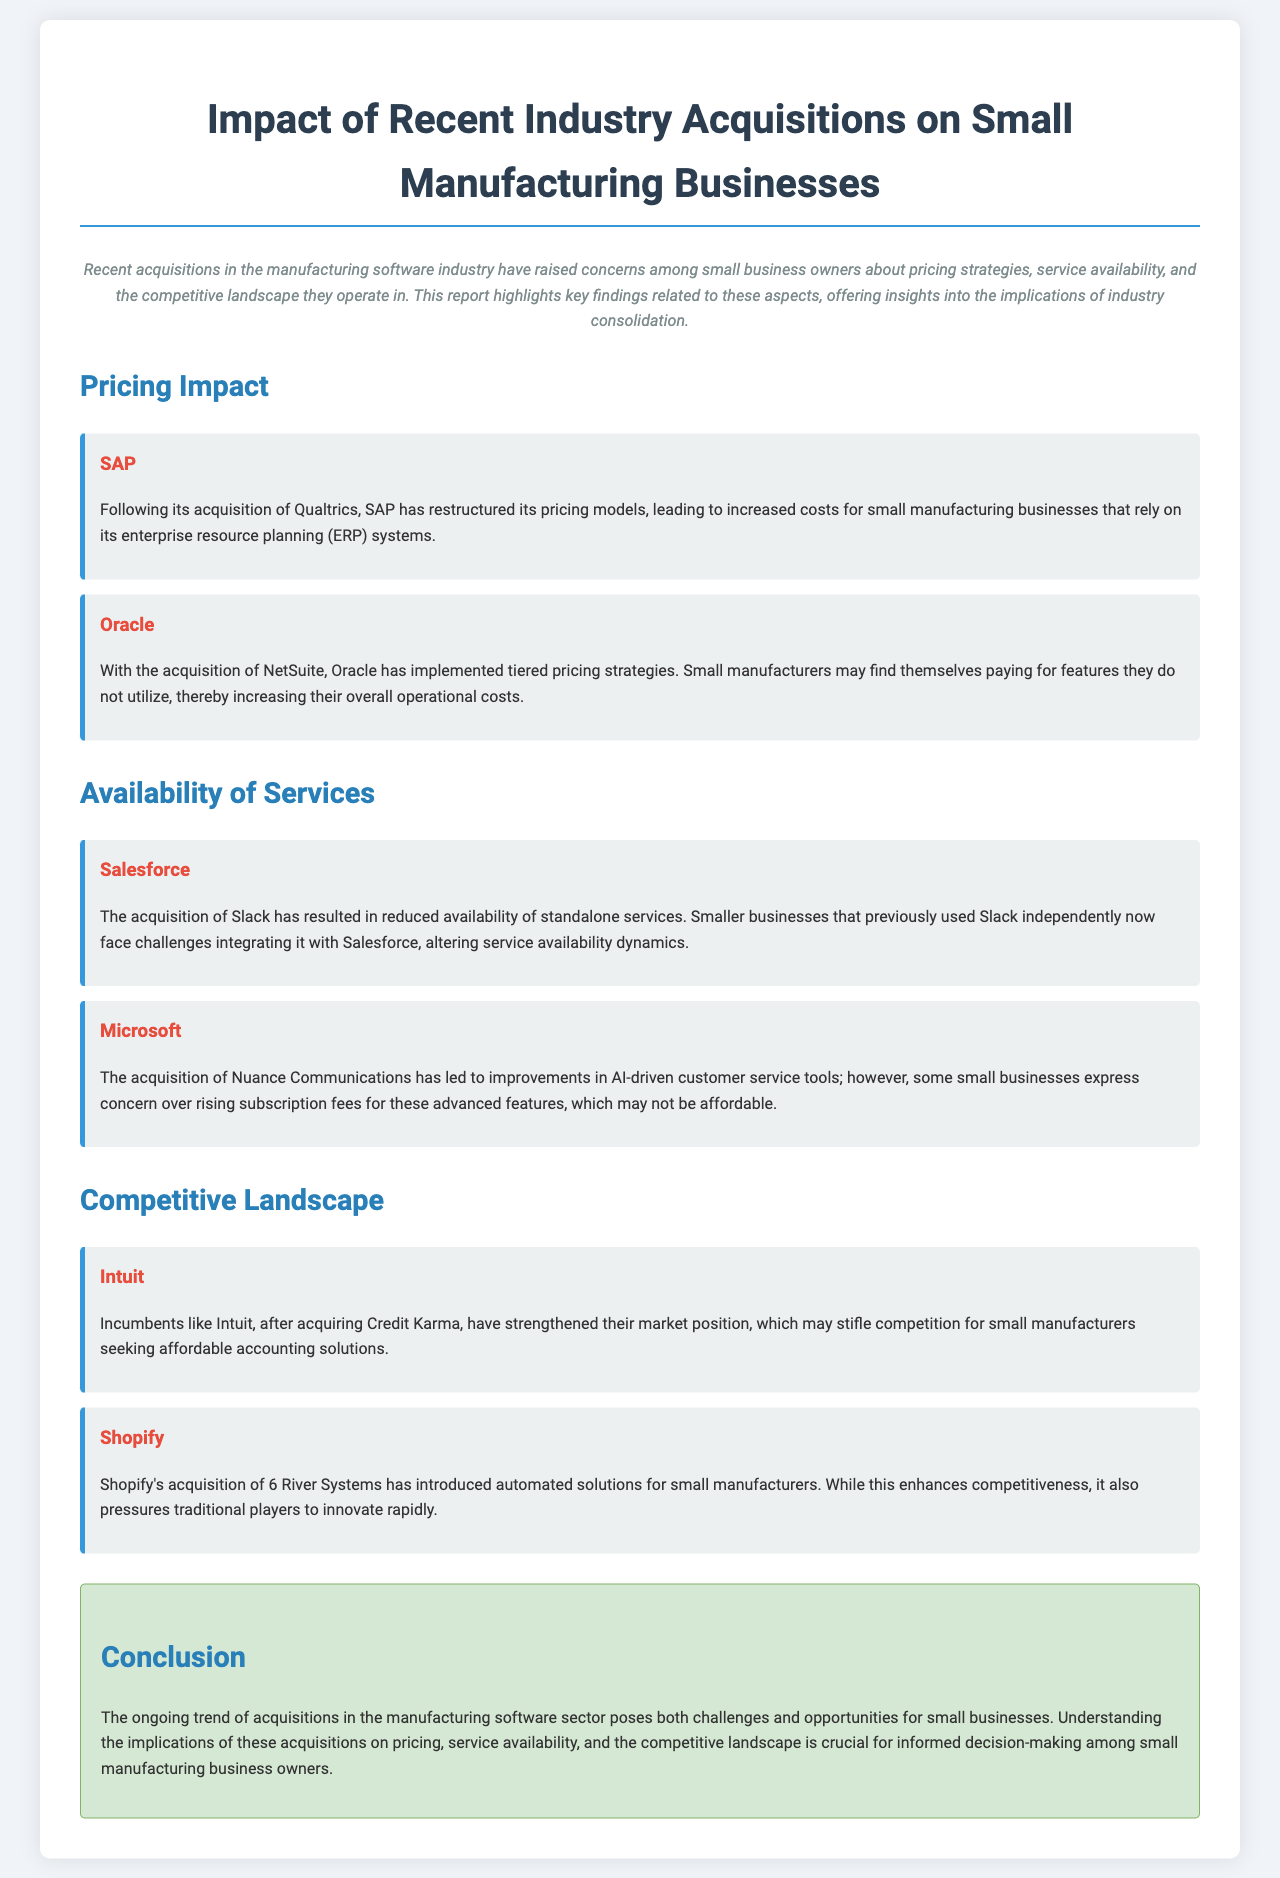what company restructured pricing models after acquiring Qualtrics? The document states that SAP restructured its pricing models following its acquisition of Qualtrics.
Answer: SAP which company implemented tiered pricing strategies after acquiring NetSuite? According to the report, Oracle implemented tiered pricing strategies after acquiring NetSuite.
Answer: Oracle which acquisition resulted in reduced availability of standalone services at Salesforce? The acquisition of Slack by Salesforce resulted in reduced availability of standalone services.
Answer: Slack what technology did Microsoft's acquisition of Nuance Communications improve? The acquisition led to improvements in AI-driven customer service tools.
Answer: AI-driven customer service tools which company strengthened its market position by acquiring Credit Karma? The document mentions that Intuit strengthened its market position by acquiring Credit Karma.
Answer: Intuit what effect did Shopify's acquisition of 6 River Systems have on traditional competitors? The acquisition pressured traditional players to innovate rapidly.
Answer: Pressured traditional players to innovate rapidly what primary concern do small manufacturers have regarding Microsoft's service offerings? Small businesses express concern over rising subscription fees for advanced features.
Answer: Rising subscription fees what overarching trend in the manufacturing software sector poses challenges for small businesses? The trend of acquisitions in the manufacturing software sector poses challenges for small businesses.
Answer: Acquisitions what is critical for small manufacturing business owners to understand in light of industry acquisitions? Understanding the implications on pricing, service availability, and the competitive landscape is crucial.
Answer: Implications on pricing, service availability, and the competitive landscape 